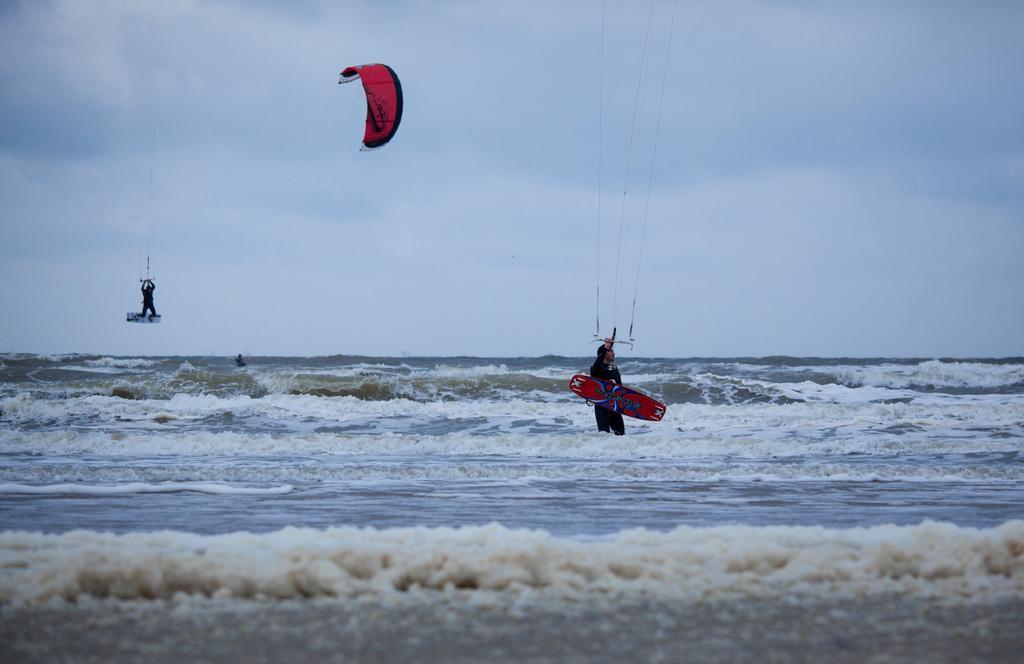How would you summarize this image in a sentence or two? In this picture we can see a person kite surfing and a man holding a surfboard with his hand and standing in water and in the background we can see the sky with clouds. 